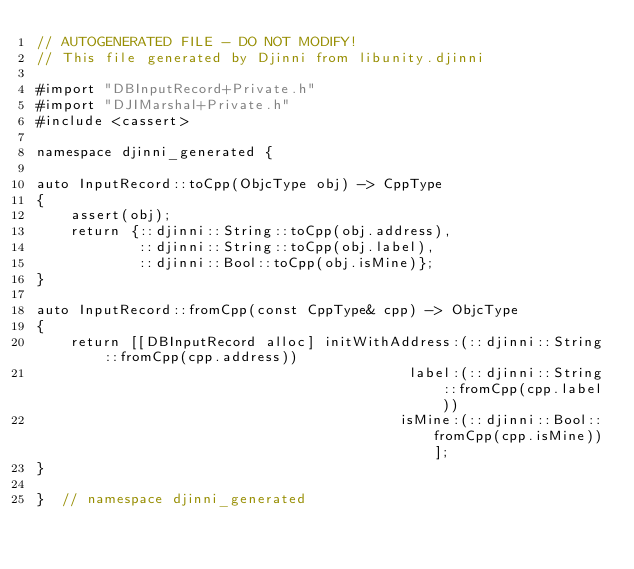Convert code to text. <code><loc_0><loc_0><loc_500><loc_500><_ObjectiveC_>// AUTOGENERATED FILE - DO NOT MODIFY!
// This file generated by Djinni from libunity.djinni

#import "DBInputRecord+Private.h"
#import "DJIMarshal+Private.h"
#include <cassert>

namespace djinni_generated {

auto InputRecord::toCpp(ObjcType obj) -> CppType
{
    assert(obj);
    return {::djinni::String::toCpp(obj.address),
            ::djinni::String::toCpp(obj.label),
            ::djinni::Bool::toCpp(obj.isMine)};
}

auto InputRecord::fromCpp(const CppType& cpp) -> ObjcType
{
    return [[DBInputRecord alloc] initWithAddress:(::djinni::String::fromCpp(cpp.address))
                                            label:(::djinni::String::fromCpp(cpp.label))
                                           isMine:(::djinni::Bool::fromCpp(cpp.isMine))];
}

}  // namespace djinni_generated
</code> 